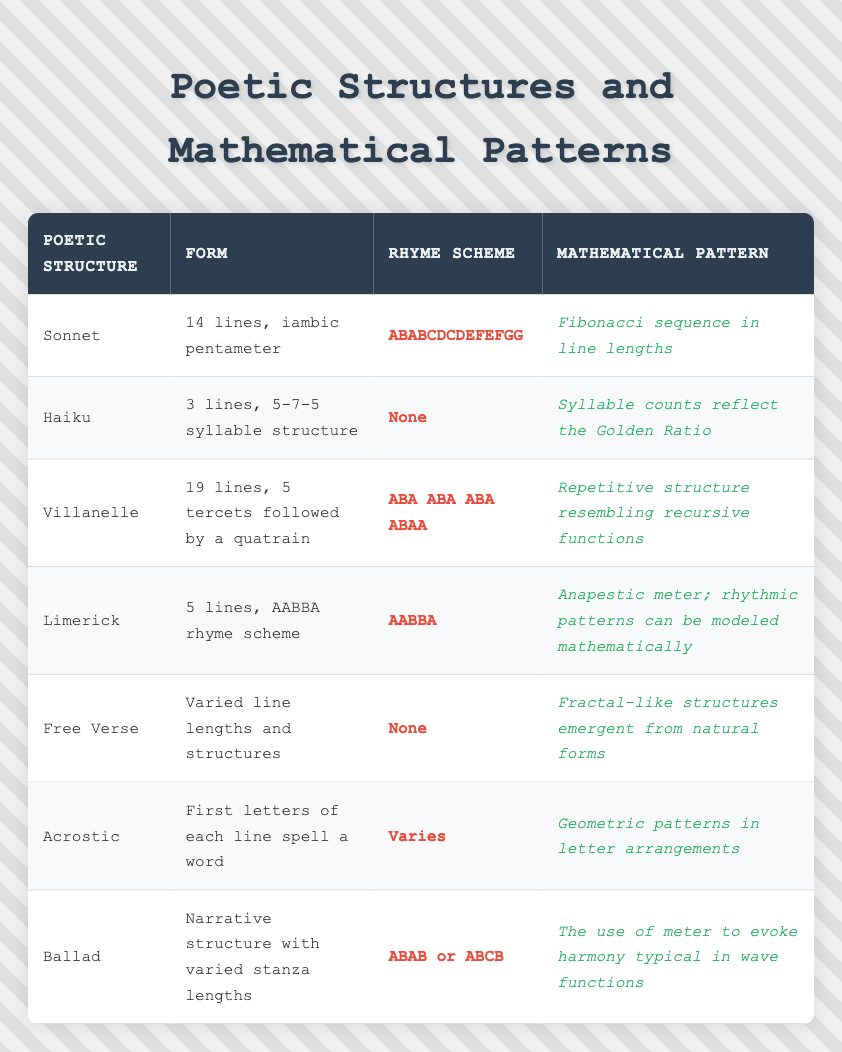What is the rhyme scheme for a Sonnet? The rhyme scheme for a Sonnet is listed in the table under the "Rhyme Scheme" column for the row labeled "Sonnet". According to the data, it is "ABABCDCDEFEFGG".
Answer: ABABCDCDEFEFGG How many lines are there in a Villanelle? The number of lines in a Villanelle can be found in the "Form" column for the row labeled "Villanelle". It states that there are 19 lines in total.
Answer: 19 lines Do Haikus have a rhyme scheme? According to the "Rhyme Scheme" column for the Haiku row, there is "None" indicated, which means Haikus do not have a rhyme scheme.
Answer: No Which poetic structure has a Fibonacci sequence in its mathematical pattern? In the table, the "Mathematical Pattern" column for the Sonnet row mentions the Fibonacci sequence related to its line lengths, making it the poetic structure with this pattern.
Answer: Sonnet What is the average number of lines across the poetic structures listed? The total number of lines includes 14 (Sonnet) + 3 (Haiku) + 19 (Villanelle) + 5 (Limerick) + an unspecified amount for Free Verse (considered variable), plus narrative structures for Ballads. To find the average, we can calculate the total for specified structures (14 + 3 + 19 + 5 = 41). Since only the Limerick, Sonnet, Villanelle, and Haiku have specific counts, we can use these four values only, ignoring Free Verse and Ballad for a simple average. Thus, 41 divided by 4 gives us 10.25.
Answer: 10.25 Is the mathematical pattern for Limericks related to rhythmic patterns? In the table under "Mathematical Pattern" for the Limerick row, it is indicated that "rhythmic patterns can be modeled mathematically", confirming its relation to rhythmic patterns.
Answer: Yes 